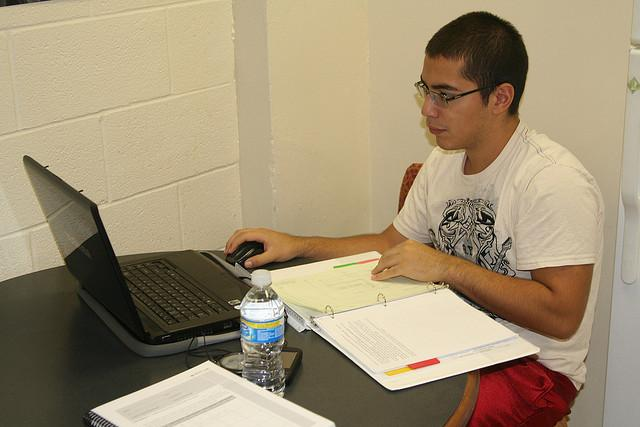Where is this student studying?

Choices:
A) dormitory
B) apartment
C) library
D) library dormitory 